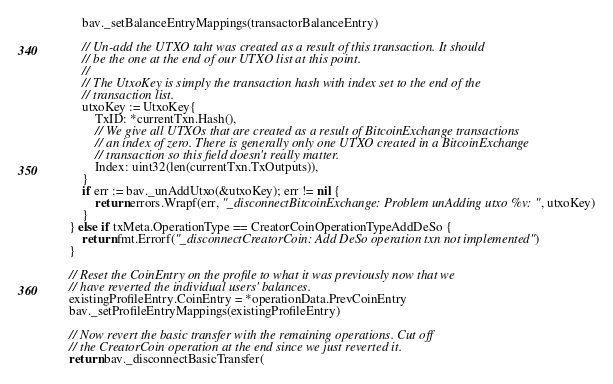Convert code to text. <code><loc_0><loc_0><loc_500><loc_500><_Go_>		bav._setBalanceEntryMappings(transactorBalanceEntry)

		// Un-add the UTXO taht was created as a result of this transaction. It should
		// be the one at the end of our UTXO list at this point.
		//
		// The UtxoKey is simply the transaction hash with index set to the end of the
		// transaction list.
		utxoKey := UtxoKey{
			TxID: *currentTxn.Hash(),
			// We give all UTXOs that are created as a result of BitcoinExchange transactions
			// an index of zero. There is generally only one UTXO created in a BitcoinExchange
			// transaction so this field doesn't really matter.
			Index: uint32(len(currentTxn.TxOutputs)),
		}
		if err := bav._unAddUtxo(&utxoKey); err != nil {
			return errors.Wrapf(err, "_disconnectBitcoinExchange: Problem unAdding utxo %v: ", utxoKey)
		}
	} else if txMeta.OperationType == CreatorCoinOperationTypeAddDeSo {
		return fmt.Errorf("_disconnectCreatorCoin: Add DeSo operation txn not implemented")
	}

	// Reset the CoinEntry on the profile to what it was previously now that we
	// have reverted the individual users' balances.
	existingProfileEntry.CoinEntry = *operationData.PrevCoinEntry
	bav._setProfileEntryMappings(existingProfileEntry)

	// Now revert the basic transfer with the remaining operations. Cut off
	// the CreatorCoin operation at the end since we just reverted it.
	return bav._disconnectBasicTransfer(</code> 